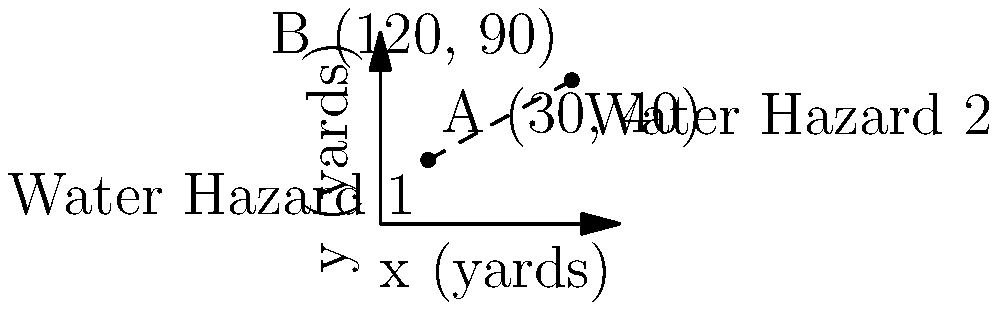As the owner of an eco-friendly golf course, you need to calculate the distance between two water hazards to plan for proper irrigation. Water Hazard 1 is located at coordinates (30, 40) and Water Hazard 2 is at (120, 90), where the units are in yards. Using the distance formula, determine the straight-line distance between these two water hazards. To find the distance between two points in a coordinate plane, we use the distance formula:

$$ d = \sqrt{(x_2 - x_1)^2 + (y_2 - y_1)^2} $$

Where $(x_1, y_1)$ are the coordinates of the first point and $(x_2, y_2)$ are the coordinates of the second point.

Given:
- Water Hazard 1: $(x_1, y_1) = (30, 40)$
- Water Hazard 2: $(x_2, y_2) = (120, 90)$

Let's plug these values into the formula:

$$ d = \sqrt{(120 - 30)^2 + (90 - 40)^2} $$

Simplify inside the parentheses:

$$ d = \sqrt{(90)^2 + (50)^2} $$

Calculate the squares:

$$ d = \sqrt{8100 + 2500} $$

Add under the square root:

$$ d = \sqrt{10600} $$

Simplify the square root:

$$ d = 102.96 $$

Therefore, the distance between the two water hazards is approximately 102.96 yards.
Answer: 102.96 yards 